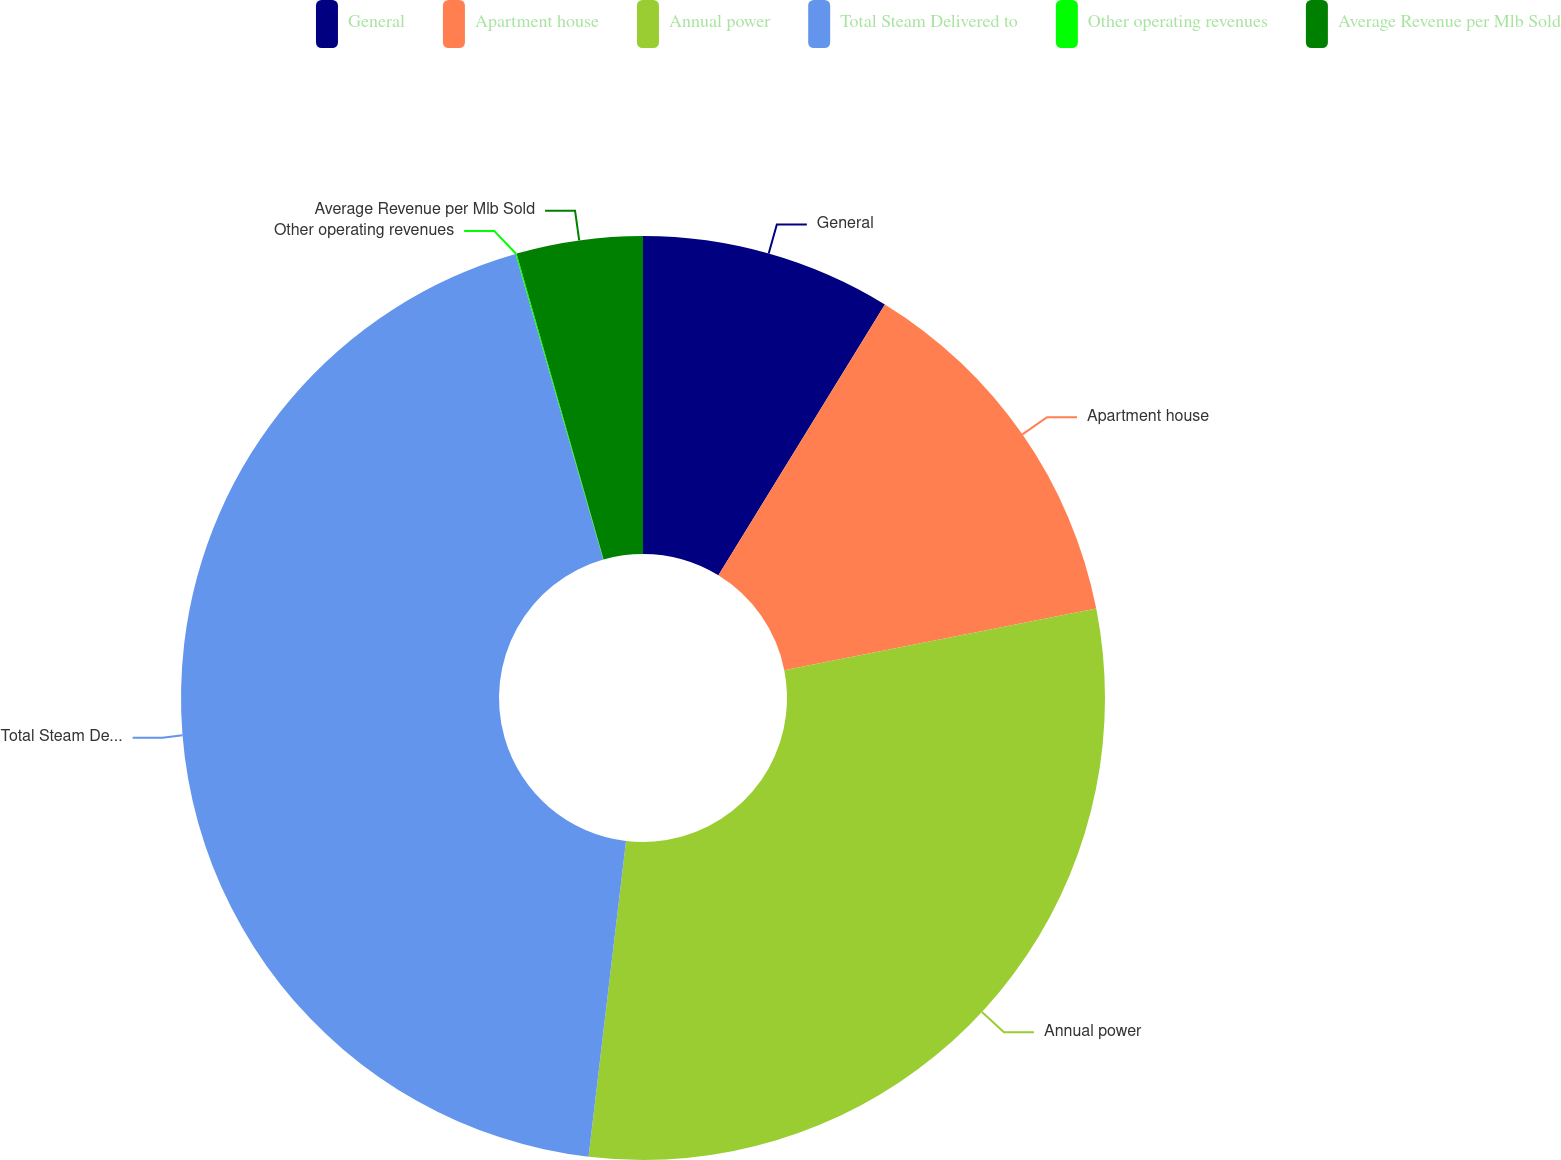Convert chart. <chart><loc_0><loc_0><loc_500><loc_500><pie_chart><fcel>General<fcel>Apartment house<fcel>Annual power<fcel>Total Steam Delivered to<fcel>Other operating revenues<fcel>Average Revenue per Mlb Sold<nl><fcel>8.77%<fcel>13.13%<fcel>29.98%<fcel>43.67%<fcel>0.04%<fcel>4.41%<nl></chart> 